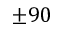<formula> <loc_0><loc_0><loc_500><loc_500>\pm 9 0</formula> 